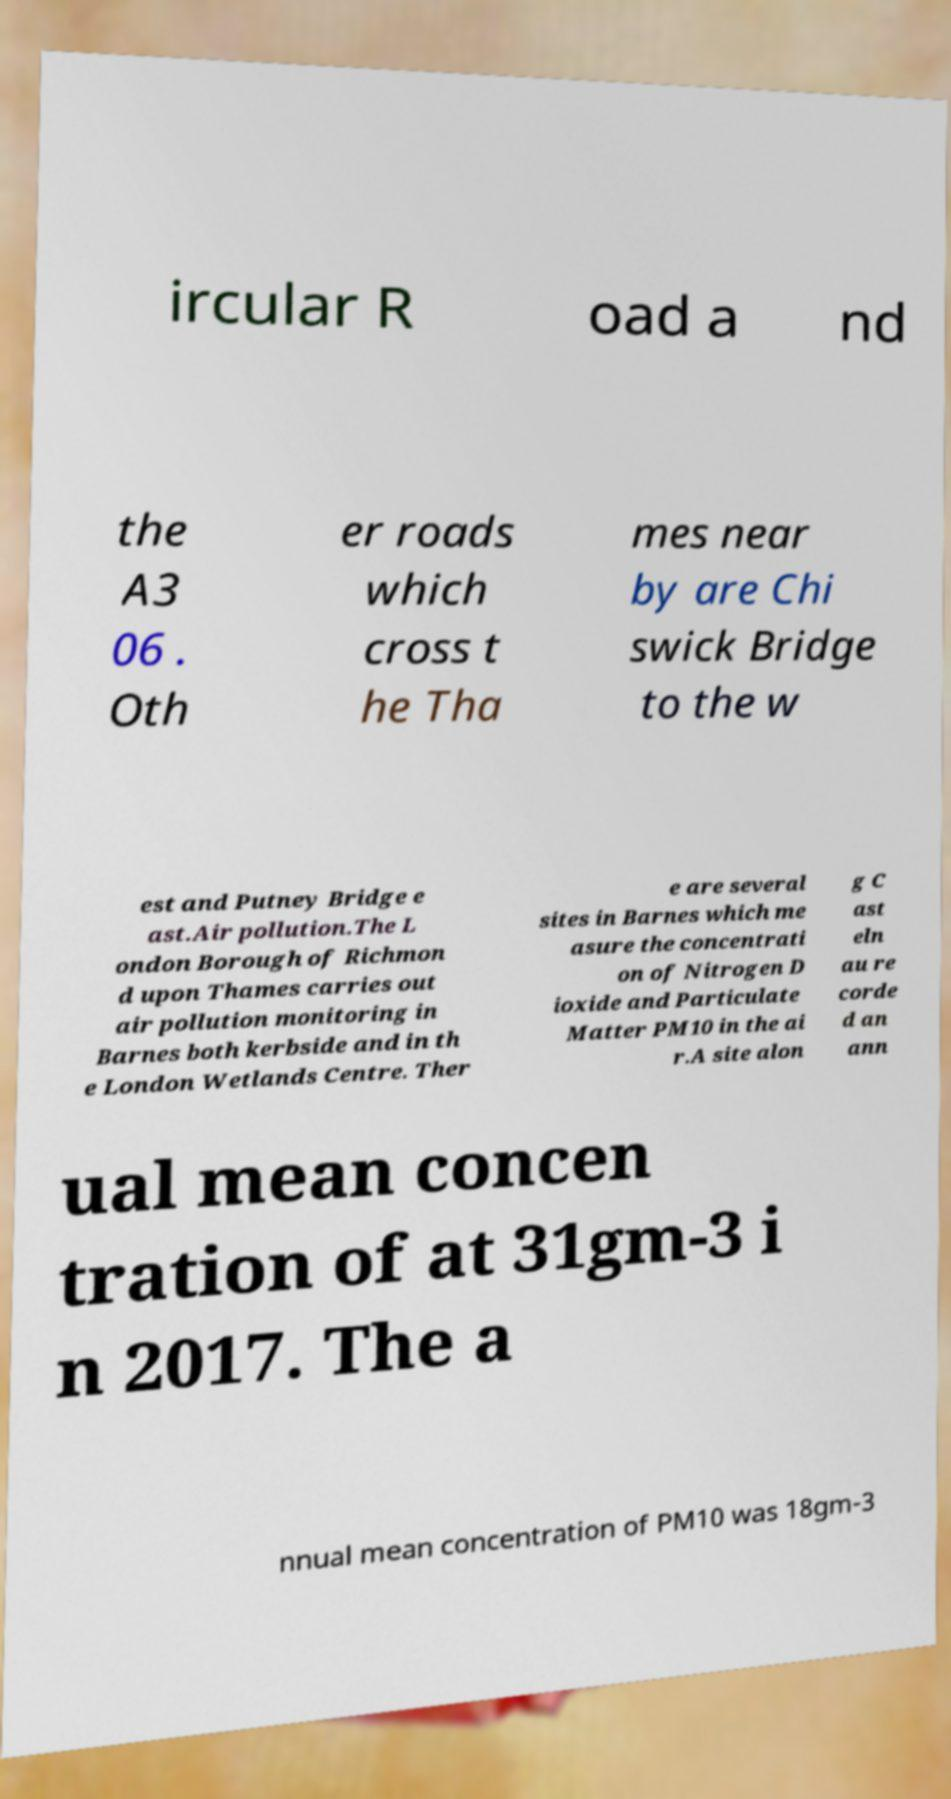I need the written content from this picture converted into text. Can you do that? ircular R oad a nd the A3 06 . Oth er roads which cross t he Tha mes near by are Chi swick Bridge to the w est and Putney Bridge e ast.Air pollution.The L ondon Borough of Richmon d upon Thames carries out air pollution monitoring in Barnes both kerbside and in th e London Wetlands Centre. Ther e are several sites in Barnes which me asure the concentrati on of Nitrogen D ioxide and Particulate Matter PM10 in the ai r.A site alon g C ast eln au re corde d an ann ual mean concen tration of at 31gm-3 i n 2017. The a nnual mean concentration of PM10 was 18gm-3 